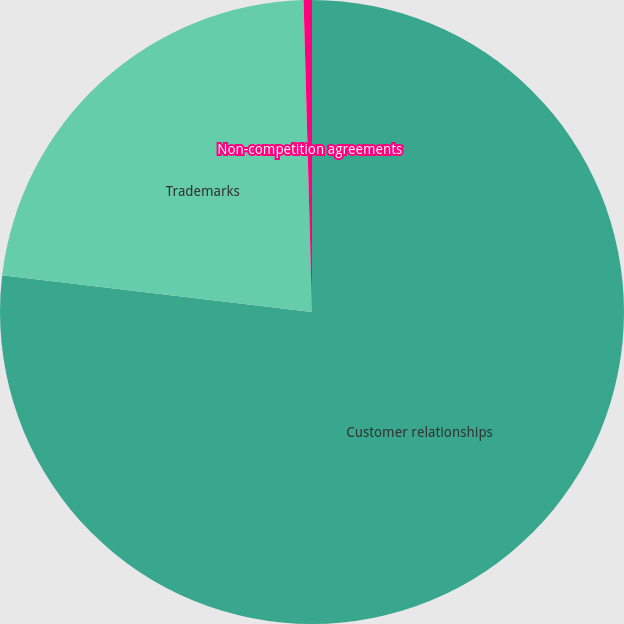<chart> <loc_0><loc_0><loc_500><loc_500><pie_chart><fcel>Customer relationships<fcel>Trademarks<fcel>Non-competition agreements<nl><fcel>76.88%<fcel>22.69%<fcel>0.43%<nl></chart> 